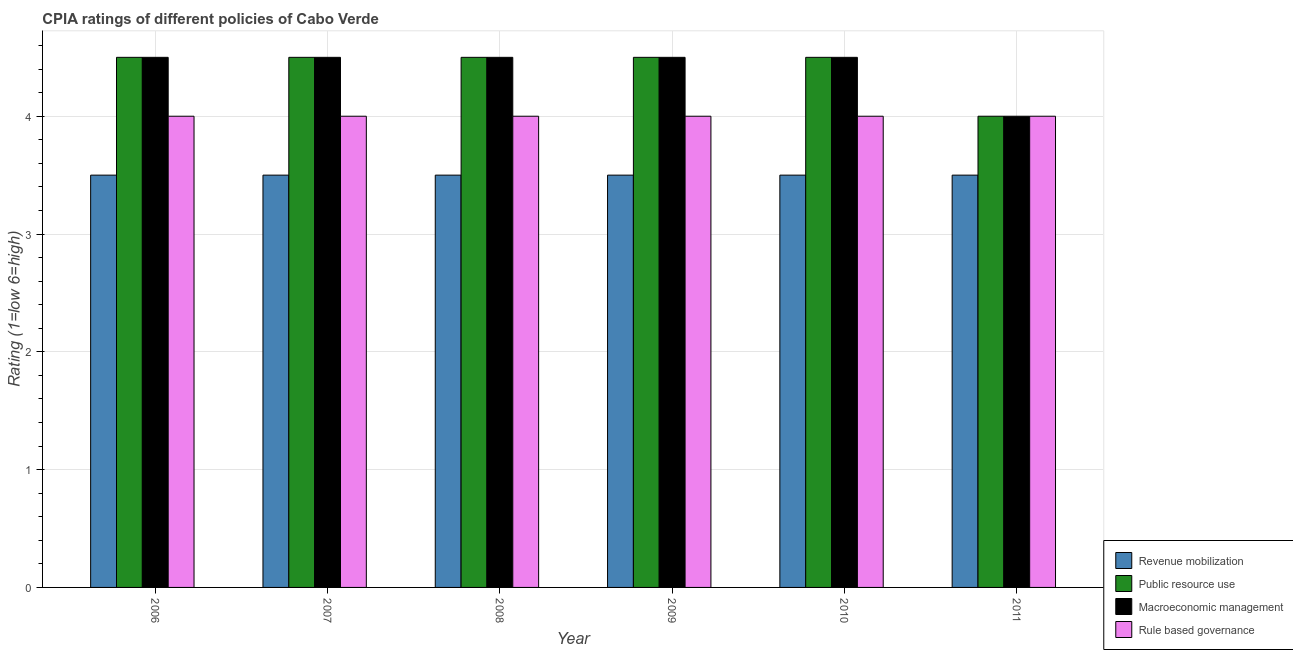What is the label of the 3rd group of bars from the left?
Make the answer very short. 2008. What is the cpia rating of revenue mobilization in 2011?
Keep it short and to the point. 3.5. Across all years, what is the maximum cpia rating of revenue mobilization?
Your answer should be very brief. 3.5. Across all years, what is the minimum cpia rating of revenue mobilization?
Your answer should be compact. 3.5. In which year was the cpia rating of macroeconomic management maximum?
Offer a very short reply. 2006. In which year was the cpia rating of public resource use minimum?
Make the answer very short. 2011. What is the total cpia rating of public resource use in the graph?
Keep it short and to the point. 26.5. What is the average cpia rating of macroeconomic management per year?
Give a very brief answer. 4.42. In the year 2011, what is the difference between the cpia rating of rule based governance and cpia rating of macroeconomic management?
Keep it short and to the point. 0. What is the ratio of the cpia rating of rule based governance in 2006 to that in 2008?
Your response must be concise. 1. Is the cpia rating of revenue mobilization in 2009 less than that in 2011?
Ensure brevity in your answer.  No. Is the difference between the cpia rating of public resource use in 2008 and 2010 greater than the difference between the cpia rating of revenue mobilization in 2008 and 2010?
Your response must be concise. No. What is the difference between the highest and the lowest cpia rating of revenue mobilization?
Make the answer very short. 0. Is the sum of the cpia rating of rule based governance in 2007 and 2008 greater than the maximum cpia rating of public resource use across all years?
Ensure brevity in your answer.  Yes. What does the 2nd bar from the left in 2008 represents?
Your answer should be very brief. Public resource use. What does the 4th bar from the right in 2007 represents?
Provide a succinct answer. Revenue mobilization. Is it the case that in every year, the sum of the cpia rating of revenue mobilization and cpia rating of public resource use is greater than the cpia rating of macroeconomic management?
Offer a terse response. Yes. How many bars are there?
Offer a terse response. 24. Are all the bars in the graph horizontal?
Offer a very short reply. No. Are the values on the major ticks of Y-axis written in scientific E-notation?
Your answer should be compact. No. How many legend labels are there?
Offer a terse response. 4. What is the title of the graph?
Provide a succinct answer. CPIA ratings of different policies of Cabo Verde. Does "Iceland" appear as one of the legend labels in the graph?
Keep it short and to the point. No. What is the label or title of the Y-axis?
Provide a short and direct response. Rating (1=low 6=high). What is the Rating (1=low 6=high) of Public resource use in 2006?
Keep it short and to the point. 4.5. What is the Rating (1=low 6=high) in Macroeconomic management in 2007?
Give a very brief answer. 4.5. What is the Rating (1=low 6=high) of Rule based governance in 2007?
Your answer should be compact. 4. What is the Rating (1=low 6=high) in Revenue mobilization in 2008?
Provide a succinct answer. 3.5. What is the Rating (1=low 6=high) in Rule based governance in 2008?
Offer a very short reply. 4. What is the Rating (1=low 6=high) of Revenue mobilization in 2009?
Ensure brevity in your answer.  3.5. What is the Rating (1=low 6=high) in Public resource use in 2009?
Offer a terse response. 4.5. What is the Rating (1=low 6=high) in Macroeconomic management in 2009?
Give a very brief answer. 4.5. What is the Rating (1=low 6=high) in Rule based governance in 2009?
Give a very brief answer. 4. What is the Rating (1=low 6=high) in Revenue mobilization in 2010?
Offer a terse response. 3.5. What is the Rating (1=low 6=high) of Rule based governance in 2010?
Make the answer very short. 4. What is the Rating (1=low 6=high) of Revenue mobilization in 2011?
Give a very brief answer. 3.5. What is the Rating (1=low 6=high) in Public resource use in 2011?
Offer a very short reply. 4. What is the Rating (1=low 6=high) of Macroeconomic management in 2011?
Your answer should be very brief. 4. What is the Rating (1=low 6=high) in Rule based governance in 2011?
Your answer should be very brief. 4. Across all years, what is the maximum Rating (1=low 6=high) of Macroeconomic management?
Your answer should be very brief. 4.5. Across all years, what is the minimum Rating (1=low 6=high) in Revenue mobilization?
Offer a very short reply. 3.5. Across all years, what is the minimum Rating (1=low 6=high) in Public resource use?
Your answer should be compact. 4. Across all years, what is the minimum Rating (1=low 6=high) of Rule based governance?
Provide a short and direct response. 4. What is the total Rating (1=low 6=high) in Revenue mobilization in the graph?
Your response must be concise. 21. What is the total Rating (1=low 6=high) in Public resource use in the graph?
Your response must be concise. 26.5. What is the total Rating (1=low 6=high) in Macroeconomic management in the graph?
Give a very brief answer. 26.5. What is the total Rating (1=low 6=high) in Rule based governance in the graph?
Ensure brevity in your answer.  24. What is the difference between the Rating (1=low 6=high) in Revenue mobilization in 2006 and that in 2007?
Offer a terse response. 0. What is the difference between the Rating (1=low 6=high) of Revenue mobilization in 2006 and that in 2008?
Ensure brevity in your answer.  0. What is the difference between the Rating (1=low 6=high) in Public resource use in 2006 and that in 2008?
Your answer should be very brief. 0. What is the difference between the Rating (1=low 6=high) of Macroeconomic management in 2006 and that in 2008?
Ensure brevity in your answer.  0. What is the difference between the Rating (1=low 6=high) in Rule based governance in 2006 and that in 2008?
Keep it short and to the point. 0. What is the difference between the Rating (1=low 6=high) of Revenue mobilization in 2006 and that in 2009?
Give a very brief answer. 0. What is the difference between the Rating (1=low 6=high) in Public resource use in 2006 and that in 2009?
Provide a succinct answer. 0. What is the difference between the Rating (1=low 6=high) in Macroeconomic management in 2006 and that in 2009?
Ensure brevity in your answer.  0. What is the difference between the Rating (1=low 6=high) in Rule based governance in 2006 and that in 2009?
Make the answer very short. 0. What is the difference between the Rating (1=low 6=high) of Rule based governance in 2006 and that in 2010?
Offer a very short reply. 0. What is the difference between the Rating (1=low 6=high) of Revenue mobilization in 2006 and that in 2011?
Make the answer very short. 0. What is the difference between the Rating (1=low 6=high) of Public resource use in 2006 and that in 2011?
Make the answer very short. 0.5. What is the difference between the Rating (1=low 6=high) of Rule based governance in 2006 and that in 2011?
Keep it short and to the point. 0. What is the difference between the Rating (1=low 6=high) of Macroeconomic management in 2007 and that in 2008?
Your answer should be very brief. 0. What is the difference between the Rating (1=low 6=high) in Revenue mobilization in 2007 and that in 2009?
Give a very brief answer. 0. What is the difference between the Rating (1=low 6=high) in Public resource use in 2007 and that in 2009?
Offer a terse response. 0. What is the difference between the Rating (1=low 6=high) of Macroeconomic management in 2007 and that in 2009?
Your answer should be very brief. 0. What is the difference between the Rating (1=low 6=high) in Rule based governance in 2007 and that in 2009?
Your response must be concise. 0. What is the difference between the Rating (1=low 6=high) in Revenue mobilization in 2007 and that in 2010?
Ensure brevity in your answer.  0. What is the difference between the Rating (1=low 6=high) in Public resource use in 2007 and that in 2010?
Your answer should be very brief. 0. What is the difference between the Rating (1=low 6=high) in Macroeconomic management in 2007 and that in 2010?
Provide a succinct answer. 0. What is the difference between the Rating (1=low 6=high) in Rule based governance in 2007 and that in 2010?
Keep it short and to the point. 0. What is the difference between the Rating (1=low 6=high) in Revenue mobilization in 2007 and that in 2011?
Your answer should be very brief. 0. What is the difference between the Rating (1=low 6=high) of Macroeconomic management in 2007 and that in 2011?
Your answer should be compact. 0.5. What is the difference between the Rating (1=low 6=high) in Rule based governance in 2007 and that in 2011?
Make the answer very short. 0. What is the difference between the Rating (1=low 6=high) of Public resource use in 2008 and that in 2009?
Your response must be concise. 0. What is the difference between the Rating (1=low 6=high) of Macroeconomic management in 2008 and that in 2009?
Provide a short and direct response. 0. What is the difference between the Rating (1=low 6=high) in Revenue mobilization in 2008 and that in 2010?
Provide a succinct answer. 0. What is the difference between the Rating (1=low 6=high) of Public resource use in 2008 and that in 2010?
Your answer should be compact. 0. What is the difference between the Rating (1=low 6=high) of Macroeconomic management in 2008 and that in 2010?
Offer a terse response. 0. What is the difference between the Rating (1=low 6=high) in Rule based governance in 2008 and that in 2010?
Ensure brevity in your answer.  0. What is the difference between the Rating (1=low 6=high) in Public resource use in 2008 and that in 2011?
Offer a terse response. 0.5. What is the difference between the Rating (1=low 6=high) in Macroeconomic management in 2008 and that in 2011?
Your response must be concise. 0.5. What is the difference between the Rating (1=low 6=high) in Public resource use in 2009 and that in 2010?
Keep it short and to the point. 0. What is the difference between the Rating (1=low 6=high) of Rule based governance in 2009 and that in 2010?
Provide a short and direct response. 0. What is the difference between the Rating (1=low 6=high) of Public resource use in 2009 and that in 2011?
Give a very brief answer. 0.5. What is the difference between the Rating (1=low 6=high) in Macroeconomic management in 2009 and that in 2011?
Offer a very short reply. 0.5. What is the difference between the Rating (1=low 6=high) of Revenue mobilization in 2010 and that in 2011?
Give a very brief answer. 0. What is the difference between the Rating (1=low 6=high) in Macroeconomic management in 2010 and that in 2011?
Ensure brevity in your answer.  0.5. What is the difference between the Rating (1=low 6=high) in Revenue mobilization in 2006 and the Rating (1=low 6=high) in Rule based governance in 2007?
Make the answer very short. -0.5. What is the difference between the Rating (1=low 6=high) in Revenue mobilization in 2006 and the Rating (1=low 6=high) in Public resource use in 2008?
Give a very brief answer. -1. What is the difference between the Rating (1=low 6=high) in Public resource use in 2006 and the Rating (1=low 6=high) in Rule based governance in 2008?
Ensure brevity in your answer.  0.5. What is the difference between the Rating (1=low 6=high) of Macroeconomic management in 2006 and the Rating (1=low 6=high) of Rule based governance in 2008?
Provide a succinct answer. 0.5. What is the difference between the Rating (1=low 6=high) in Public resource use in 2006 and the Rating (1=low 6=high) in Macroeconomic management in 2009?
Provide a succinct answer. 0. What is the difference between the Rating (1=low 6=high) of Public resource use in 2006 and the Rating (1=low 6=high) of Rule based governance in 2009?
Make the answer very short. 0.5. What is the difference between the Rating (1=low 6=high) in Public resource use in 2006 and the Rating (1=low 6=high) in Macroeconomic management in 2010?
Ensure brevity in your answer.  0. What is the difference between the Rating (1=low 6=high) in Public resource use in 2006 and the Rating (1=low 6=high) in Rule based governance in 2010?
Your answer should be compact. 0.5. What is the difference between the Rating (1=low 6=high) of Macroeconomic management in 2006 and the Rating (1=low 6=high) of Rule based governance in 2010?
Your answer should be very brief. 0.5. What is the difference between the Rating (1=low 6=high) of Revenue mobilization in 2006 and the Rating (1=low 6=high) of Macroeconomic management in 2011?
Give a very brief answer. -0.5. What is the difference between the Rating (1=low 6=high) in Revenue mobilization in 2006 and the Rating (1=low 6=high) in Rule based governance in 2011?
Provide a short and direct response. -0.5. What is the difference between the Rating (1=low 6=high) of Public resource use in 2006 and the Rating (1=low 6=high) of Rule based governance in 2011?
Provide a short and direct response. 0.5. What is the difference between the Rating (1=low 6=high) of Revenue mobilization in 2007 and the Rating (1=low 6=high) of Public resource use in 2008?
Make the answer very short. -1. What is the difference between the Rating (1=low 6=high) of Public resource use in 2007 and the Rating (1=low 6=high) of Macroeconomic management in 2008?
Give a very brief answer. 0. What is the difference between the Rating (1=low 6=high) of Public resource use in 2007 and the Rating (1=low 6=high) of Rule based governance in 2008?
Ensure brevity in your answer.  0.5. What is the difference between the Rating (1=low 6=high) in Macroeconomic management in 2007 and the Rating (1=low 6=high) in Rule based governance in 2008?
Ensure brevity in your answer.  0.5. What is the difference between the Rating (1=low 6=high) in Revenue mobilization in 2007 and the Rating (1=low 6=high) in Public resource use in 2009?
Keep it short and to the point. -1. What is the difference between the Rating (1=low 6=high) in Revenue mobilization in 2007 and the Rating (1=low 6=high) in Public resource use in 2010?
Your answer should be compact. -1. What is the difference between the Rating (1=low 6=high) of Revenue mobilization in 2007 and the Rating (1=low 6=high) of Rule based governance in 2010?
Your answer should be compact. -0.5. What is the difference between the Rating (1=low 6=high) in Public resource use in 2007 and the Rating (1=low 6=high) in Macroeconomic management in 2010?
Make the answer very short. 0. What is the difference between the Rating (1=low 6=high) in Public resource use in 2007 and the Rating (1=low 6=high) in Rule based governance in 2010?
Offer a very short reply. 0.5. What is the difference between the Rating (1=low 6=high) in Revenue mobilization in 2007 and the Rating (1=low 6=high) in Public resource use in 2011?
Keep it short and to the point. -0.5. What is the difference between the Rating (1=low 6=high) in Revenue mobilization in 2007 and the Rating (1=low 6=high) in Macroeconomic management in 2011?
Your answer should be very brief. -0.5. What is the difference between the Rating (1=low 6=high) of Revenue mobilization in 2007 and the Rating (1=low 6=high) of Rule based governance in 2011?
Your answer should be very brief. -0.5. What is the difference between the Rating (1=low 6=high) in Macroeconomic management in 2007 and the Rating (1=low 6=high) in Rule based governance in 2011?
Give a very brief answer. 0.5. What is the difference between the Rating (1=low 6=high) of Revenue mobilization in 2008 and the Rating (1=low 6=high) of Public resource use in 2009?
Provide a short and direct response. -1. What is the difference between the Rating (1=low 6=high) in Revenue mobilization in 2008 and the Rating (1=low 6=high) in Macroeconomic management in 2009?
Make the answer very short. -1. What is the difference between the Rating (1=low 6=high) in Revenue mobilization in 2008 and the Rating (1=low 6=high) in Macroeconomic management in 2010?
Offer a very short reply. -1. What is the difference between the Rating (1=low 6=high) of Revenue mobilization in 2008 and the Rating (1=low 6=high) of Rule based governance in 2010?
Provide a succinct answer. -0.5. What is the difference between the Rating (1=low 6=high) in Public resource use in 2008 and the Rating (1=low 6=high) in Macroeconomic management in 2010?
Your answer should be very brief. 0. What is the difference between the Rating (1=low 6=high) in Public resource use in 2008 and the Rating (1=low 6=high) in Rule based governance in 2010?
Keep it short and to the point. 0.5. What is the difference between the Rating (1=low 6=high) in Revenue mobilization in 2008 and the Rating (1=low 6=high) in Public resource use in 2011?
Offer a very short reply. -0.5. What is the difference between the Rating (1=low 6=high) of Revenue mobilization in 2008 and the Rating (1=low 6=high) of Macroeconomic management in 2011?
Provide a succinct answer. -0.5. What is the difference between the Rating (1=low 6=high) in Macroeconomic management in 2008 and the Rating (1=low 6=high) in Rule based governance in 2011?
Provide a succinct answer. 0.5. What is the difference between the Rating (1=low 6=high) in Revenue mobilization in 2009 and the Rating (1=low 6=high) in Public resource use in 2010?
Your answer should be very brief. -1. What is the difference between the Rating (1=low 6=high) in Public resource use in 2009 and the Rating (1=low 6=high) in Macroeconomic management in 2010?
Your response must be concise. 0. What is the difference between the Rating (1=low 6=high) of Macroeconomic management in 2009 and the Rating (1=low 6=high) of Rule based governance in 2011?
Ensure brevity in your answer.  0.5. What is the difference between the Rating (1=low 6=high) in Revenue mobilization in 2010 and the Rating (1=low 6=high) in Public resource use in 2011?
Your response must be concise. -0.5. What is the difference between the Rating (1=low 6=high) of Public resource use in 2010 and the Rating (1=low 6=high) of Macroeconomic management in 2011?
Your response must be concise. 0.5. What is the difference between the Rating (1=low 6=high) of Public resource use in 2010 and the Rating (1=low 6=high) of Rule based governance in 2011?
Offer a very short reply. 0.5. What is the difference between the Rating (1=low 6=high) in Macroeconomic management in 2010 and the Rating (1=low 6=high) in Rule based governance in 2011?
Provide a short and direct response. 0.5. What is the average Rating (1=low 6=high) in Public resource use per year?
Give a very brief answer. 4.42. What is the average Rating (1=low 6=high) in Macroeconomic management per year?
Give a very brief answer. 4.42. What is the average Rating (1=low 6=high) of Rule based governance per year?
Give a very brief answer. 4. In the year 2006, what is the difference between the Rating (1=low 6=high) of Revenue mobilization and Rating (1=low 6=high) of Public resource use?
Offer a terse response. -1. In the year 2006, what is the difference between the Rating (1=low 6=high) of Public resource use and Rating (1=low 6=high) of Macroeconomic management?
Provide a short and direct response. 0. In the year 2006, what is the difference between the Rating (1=low 6=high) in Public resource use and Rating (1=low 6=high) in Rule based governance?
Keep it short and to the point. 0.5. In the year 2006, what is the difference between the Rating (1=low 6=high) of Macroeconomic management and Rating (1=low 6=high) of Rule based governance?
Give a very brief answer. 0.5. In the year 2007, what is the difference between the Rating (1=low 6=high) of Revenue mobilization and Rating (1=low 6=high) of Rule based governance?
Make the answer very short. -0.5. In the year 2007, what is the difference between the Rating (1=low 6=high) in Public resource use and Rating (1=low 6=high) in Macroeconomic management?
Make the answer very short. 0. In the year 2007, what is the difference between the Rating (1=low 6=high) of Public resource use and Rating (1=low 6=high) of Rule based governance?
Make the answer very short. 0.5. In the year 2007, what is the difference between the Rating (1=low 6=high) in Macroeconomic management and Rating (1=low 6=high) in Rule based governance?
Offer a very short reply. 0.5. In the year 2008, what is the difference between the Rating (1=low 6=high) of Revenue mobilization and Rating (1=low 6=high) of Rule based governance?
Your answer should be very brief. -0.5. In the year 2009, what is the difference between the Rating (1=low 6=high) of Revenue mobilization and Rating (1=low 6=high) of Public resource use?
Ensure brevity in your answer.  -1. In the year 2009, what is the difference between the Rating (1=low 6=high) in Revenue mobilization and Rating (1=low 6=high) in Macroeconomic management?
Provide a succinct answer. -1. In the year 2009, what is the difference between the Rating (1=low 6=high) of Revenue mobilization and Rating (1=low 6=high) of Rule based governance?
Provide a short and direct response. -0.5. In the year 2009, what is the difference between the Rating (1=low 6=high) of Public resource use and Rating (1=low 6=high) of Macroeconomic management?
Your response must be concise. 0. In the year 2010, what is the difference between the Rating (1=low 6=high) in Revenue mobilization and Rating (1=low 6=high) in Macroeconomic management?
Offer a very short reply. -1. In the year 2010, what is the difference between the Rating (1=low 6=high) in Revenue mobilization and Rating (1=low 6=high) in Rule based governance?
Offer a very short reply. -0.5. In the year 2010, what is the difference between the Rating (1=low 6=high) of Macroeconomic management and Rating (1=low 6=high) of Rule based governance?
Keep it short and to the point. 0.5. In the year 2011, what is the difference between the Rating (1=low 6=high) of Revenue mobilization and Rating (1=low 6=high) of Public resource use?
Your response must be concise. -0.5. In the year 2011, what is the difference between the Rating (1=low 6=high) in Revenue mobilization and Rating (1=low 6=high) in Macroeconomic management?
Your answer should be compact. -0.5. In the year 2011, what is the difference between the Rating (1=low 6=high) of Public resource use and Rating (1=low 6=high) of Rule based governance?
Provide a succinct answer. 0. What is the ratio of the Rating (1=low 6=high) of Revenue mobilization in 2006 to that in 2007?
Offer a terse response. 1. What is the ratio of the Rating (1=low 6=high) in Public resource use in 2006 to that in 2007?
Your response must be concise. 1. What is the ratio of the Rating (1=low 6=high) of Rule based governance in 2006 to that in 2007?
Offer a terse response. 1. What is the ratio of the Rating (1=low 6=high) in Revenue mobilization in 2006 to that in 2008?
Ensure brevity in your answer.  1. What is the ratio of the Rating (1=low 6=high) of Public resource use in 2006 to that in 2008?
Offer a very short reply. 1. What is the ratio of the Rating (1=low 6=high) of Macroeconomic management in 2006 to that in 2008?
Your answer should be very brief. 1. What is the ratio of the Rating (1=low 6=high) in Rule based governance in 2006 to that in 2008?
Ensure brevity in your answer.  1. What is the ratio of the Rating (1=low 6=high) in Public resource use in 2006 to that in 2009?
Your response must be concise. 1. What is the ratio of the Rating (1=low 6=high) in Rule based governance in 2006 to that in 2009?
Offer a very short reply. 1. What is the ratio of the Rating (1=low 6=high) in Revenue mobilization in 2006 to that in 2010?
Give a very brief answer. 1. What is the ratio of the Rating (1=low 6=high) in Public resource use in 2006 to that in 2010?
Keep it short and to the point. 1. What is the ratio of the Rating (1=low 6=high) of Macroeconomic management in 2006 to that in 2010?
Provide a short and direct response. 1. What is the ratio of the Rating (1=low 6=high) of Public resource use in 2006 to that in 2011?
Provide a succinct answer. 1.12. What is the ratio of the Rating (1=low 6=high) of Macroeconomic management in 2006 to that in 2011?
Offer a very short reply. 1.12. What is the ratio of the Rating (1=low 6=high) in Revenue mobilization in 2007 to that in 2008?
Give a very brief answer. 1. What is the ratio of the Rating (1=low 6=high) of Public resource use in 2007 to that in 2008?
Keep it short and to the point. 1. What is the ratio of the Rating (1=low 6=high) of Public resource use in 2007 to that in 2009?
Offer a very short reply. 1. What is the ratio of the Rating (1=low 6=high) in Macroeconomic management in 2007 to that in 2009?
Make the answer very short. 1. What is the ratio of the Rating (1=low 6=high) in Rule based governance in 2007 to that in 2009?
Offer a terse response. 1. What is the ratio of the Rating (1=low 6=high) of Revenue mobilization in 2007 to that in 2010?
Provide a succinct answer. 1. What is the ratio of the Rating (1=low 6=high) of Public resource use in 2007 to that in 2010?
Offer a terse response. 1. What is the ratio of the Rating (1=low 6=high) of Macroeconomic management in 2007 to that in 2010?
Offer a terse response. 1. What is the ratio of the Rating (1=low 6=high) in Rule based governance in 2007 to that in 2010?
Offer a very short reply. 1. What is the ratio of the Rating (1=low 6=high) in Revenue mobilization in 2007 to that in 2011?
Provide a short and direct response. 1. What is the ratio of the Rating (1=low 6=high) in Public resource use in 2007 to that in 2011?
Make the answer very short. 1.12. What is the ratio of the Rating (1=low 6=high) of Macroeconomic management in 2007 to that in 2011?
Your response must be concise. 1.12. What is the ratio of the Rating (1=low 6=high) of Rule based governance in 2007 to that in 2011?
Provide a short and direct response. 1. What is the ratio of the Rating (1=low 6=high) of Revenue mobilization in 2008 to that in 2009?
Offer a terse response. 1. What is the ratio of the Rating (1=low 6=high) in Macroeconomic management in 2008 to that in 2009?
Your answer should be compact. 1. What is the ratio of the Rating (1=low 6=high) in Revenue mobilization in 2008 to that in 2010?
Make the answer very short. 1. What is the ratio of the Rating (1=low 6=high) in Revenue mobilization in 2008 to that in 2011?
Ensure brevity in your answer.  1. What is the ratio of the Rating (1=low 6=high) of Macroeconomic management in 2008 to that in 2011?
Your answer should be compact. 1.12. What is the ratio of the Rating (1=low 6=high) of Public resource use in 2009 to that in 2010?
Provide a succinct answer. 1. What is the ratio of the Rating (1=low 6=high) in Revenue mobilization in 2009 to that in 2011?
Ensure brevity in your answer.  1. What is the ratio of the Rating (1=low 6=high) in Public resource use in 2009 to that in 2011?
Give a very brief answer. 1.12. What is the ratio of the Rating (1=low 6=high) of Rule based governance in 2009 to that in 2011?
Provide a short and direct response. 1. What is the ratio of the Rating (1=low 6=high) of Revenue mobilization in 2010 to that in 2011?
Make the answer very short. 1. What is the ratio of the Rating (1=low 6=high) in Rule based governance in 2010 to that in 2011?
Your answer should be very brief. 1. What is the difference between the highest and the second highest Rating (1=low 6=high) in Revenue mobilization?
Keep it short and to the point. 0. What is the difference between the highest and the second highest Rating (1=low 6=high) of Rule based governance?
Ensure brevity in your answer.  0. 